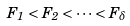<formula> <loc_0><loc_0><loc_500><loc_500>F _ { 1 } < F _ { 2 } < \dots < F _ { \delta }</formula> 